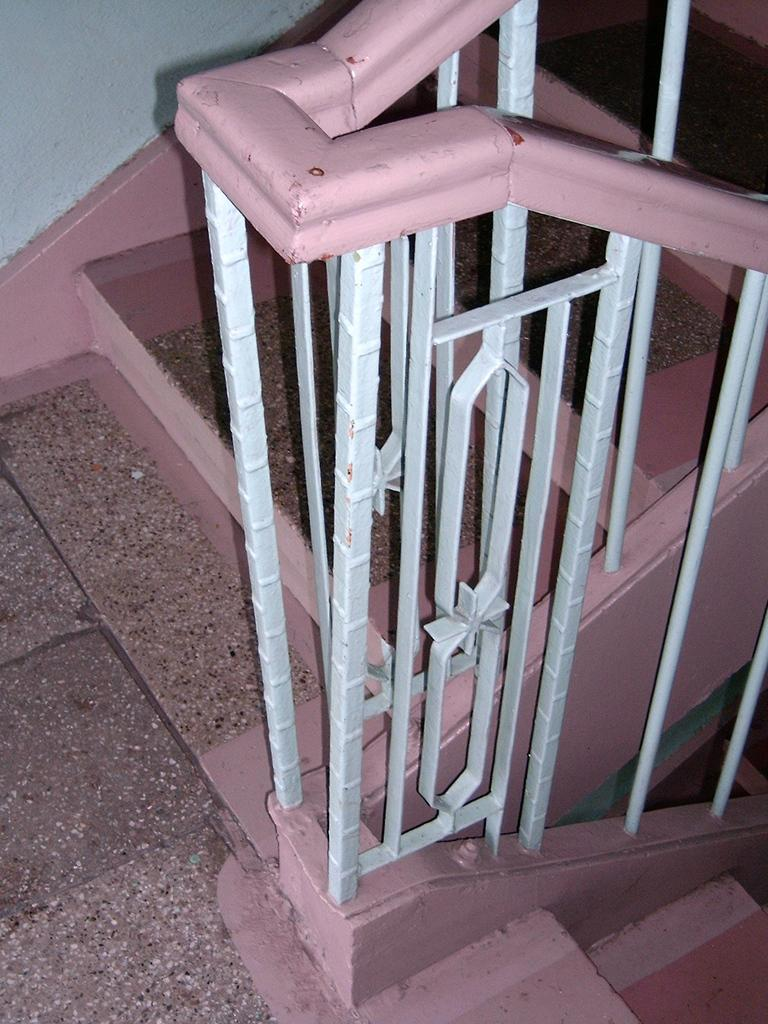What type of architectural feature is present in the image? There are steps in the image. What safety feature is present beside the steps? There is a railing beside the steps. What other structural element can be seen in the image? There is a wall in the top left of the image. What type of glass is used to make the zoo enclosure in the image? There is no zoo or glass present in the image; it features steps and a railing. 